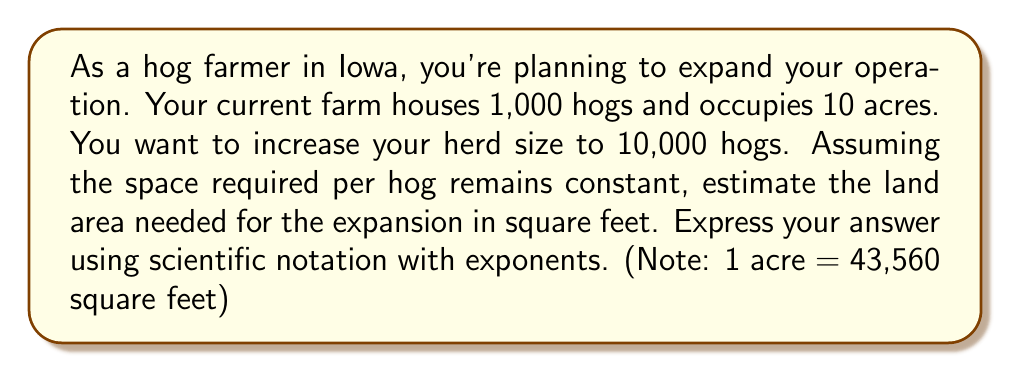Teach me how to tackle this problem. Let's approach this step-by-step:

1) First, let's calculate the current space per hog:
   $\frac{10 \text{ acres}}{1,000 \text{ hogs}} = 0.01 \text{ acres per hog}$

2) Now, let's convert acres to square feet:
   $0.01 \text{ acres} \times 43,560 \frac{\text{ft}^2}{\text{acre}} = 435.6 \text{ ft}^2 \text{ per hog}$

3) For 10,000 hogs, we'll need:
   $10,000 \text{ hogs} \times 435.6 \frac{\text{ft}^2}{\text{hog}} = 4,356,000 \text{ ft}^2$

4) To express this in scientific notation with exponents:
   $4,356,000 = 4.356 \times 10^6 \text{ ft}^2$

Therefore, the estimated land area needed for the expansion is $4.356 \times 10^6 \text{ ft}^2$.
Answer: $4.356 \times 10^6 \text{ ft}^2$ 